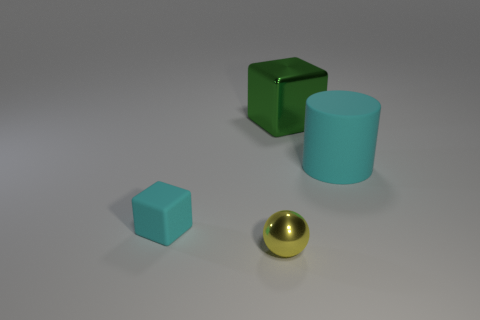How does the lighting in the image suggest the texture of the objects? The lighting creates soft shadows and highlights on the objects, suggesting they have smooth surfaces. The reflections, especially on the golden sphere, imply a metallic and perhaps polished surface, while the other objects have diffuse reflections that might suggest a matte or satin finish, like plastic. 